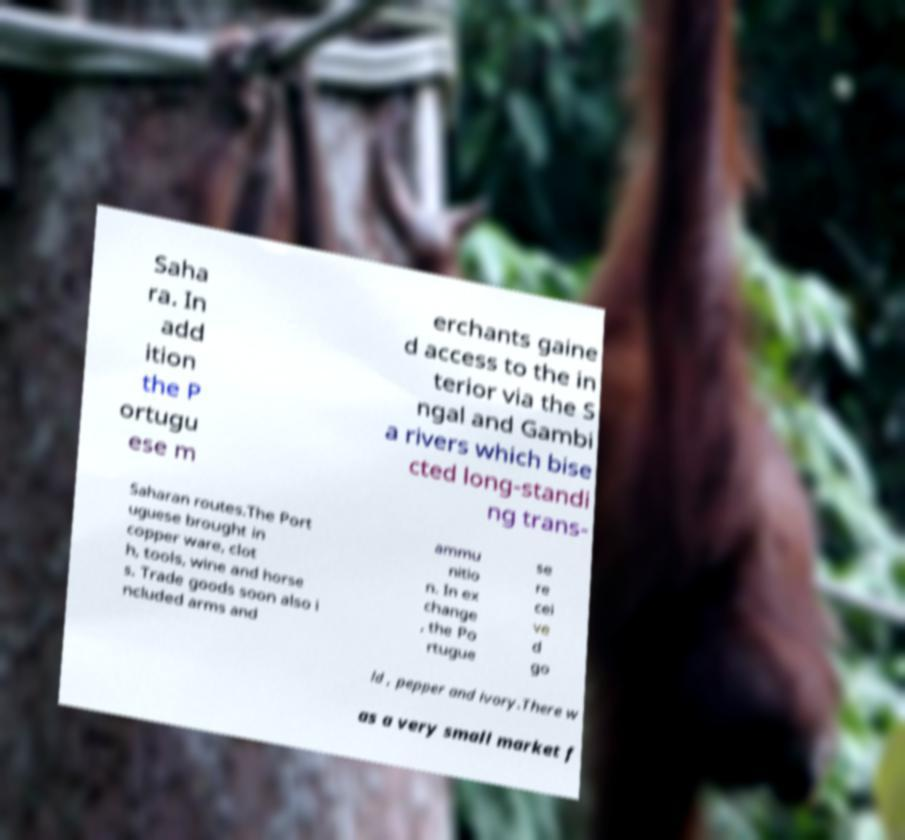Please identify and transcribe the text found in this image. Saha ra. In add ition the P ortugu ese m erchants gaine d access to the in terior via the S ngal and Gambi a rivers which bise cted long-standi ng trans- Saharan routes.The Port uguese brought in copper ware, clot h, tools, wine and horse s. Trade goods soon also i ncluded arms and ammu nitio n. In ex change , the Po rtugue se re cei ve d go ld , pepper and ivory.There w as a very small market f 